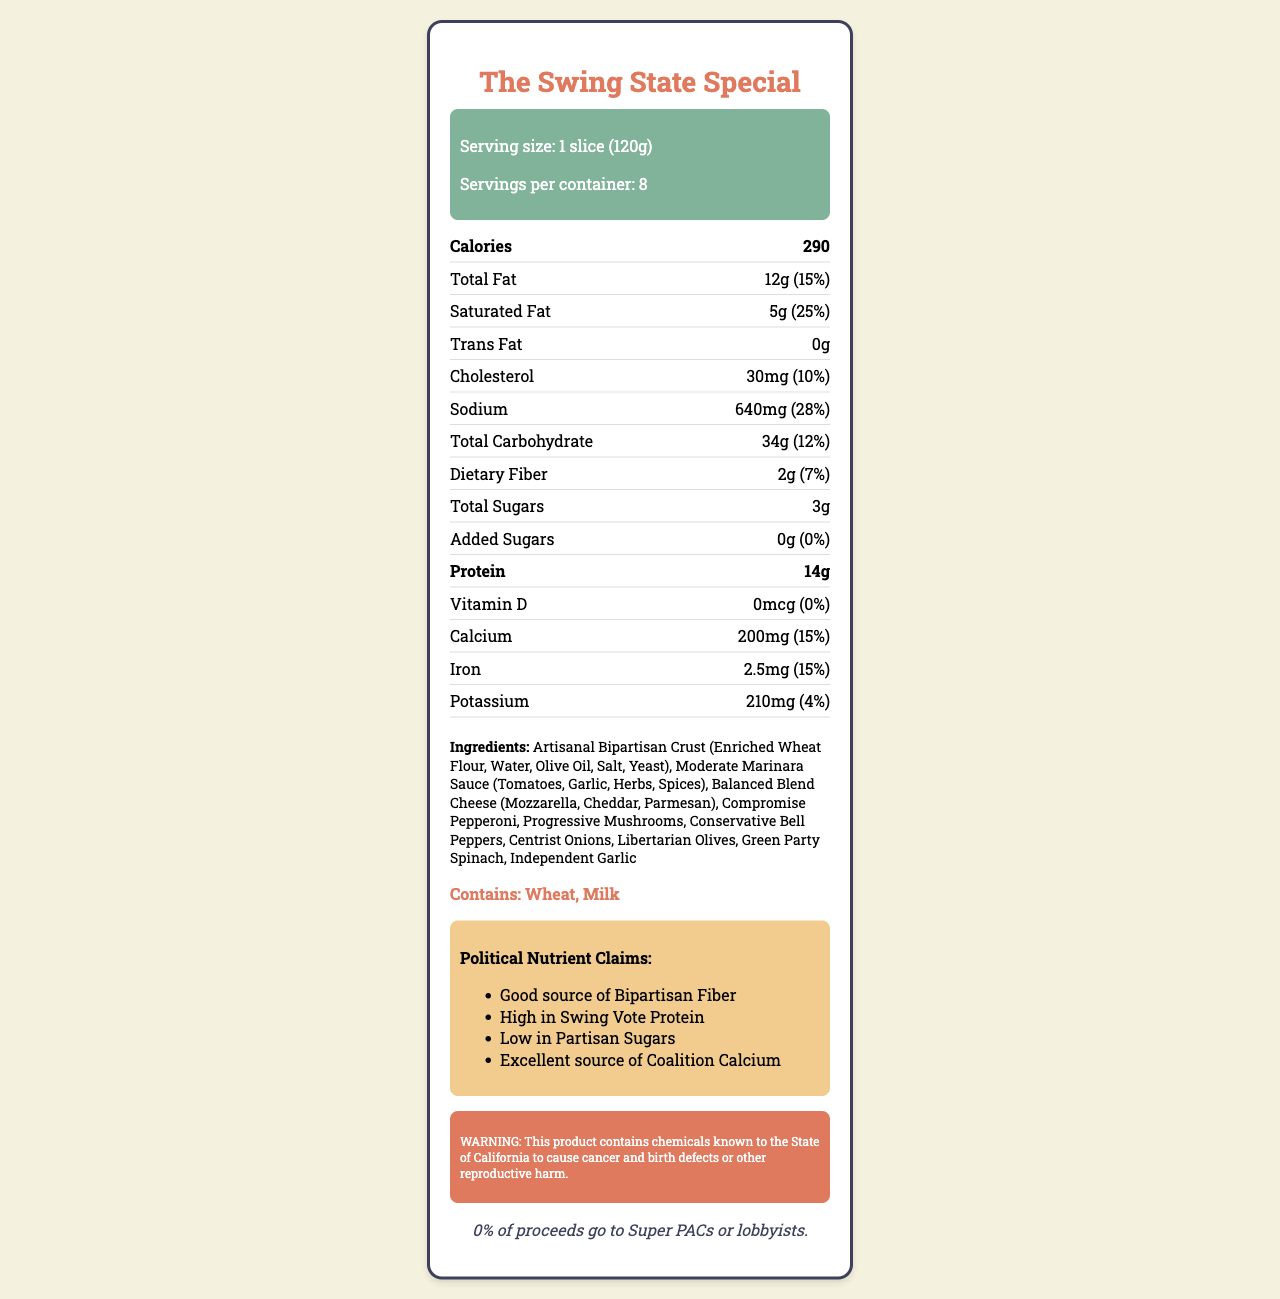what is the serving size for "The Swing State Special" pizza? The serving size for 'The Swing State Special' pizza is shown as 1 slice (120g) in the "Serving size" section.
Answer: 1 slice (120g) how many servings are there per container? The document states that there are 8 servings per container in the "Servings per container" section.
Answer: 8 what are the total calories in one serving? The number of calories in one serving is listed as 290 in the "Calories" section.
Answer: 290 what are the political nutrient claims mentioned? The "Political Nutrient Claims" section lists four claims: "Good source of Bipartisan Fiber", "High in Swing Vote Protein", "Low in Partisan Sugars", and "Excellent source of Coalition Calcium".
Answer: Good source of Bipartisan Fiber, High in Swing Vote Protein, Low in Partisan Sugars, Excellent source of Coalition Calcium what allergens are present in the pizza? The "Allergens" section specifies that the pizza contains Wheat and Milk.
Answer: Wheat, Milk how much total fat is in one slice (in grams)? A. 10g B. 12g C. 14g D. 16g The total fat in one slice is listed as 12g in the "Total Fat" section.
Answer: B what is the daily value percentage of sodium in one serving? A. 18% B. 20% C. 25% D. 28% The daily value percentage of sodium in one serving is 28%, as indicated in the "Sodium" section.
Answer: D does the product contain any Trans Fat? The "Trans Fat" section shows 0g, indicating that the product does not contain any Trans Fat.
Answer: No what ingredients make up the "Balanced Blend Cheese"? The "Ingredients" section lists the components of the "Balanced Blend Cheese" as Mozzarella, Cheddar, and Parmesan.
Answer: Mozzarella, Cheddar, Parmesan does this pizza meet any dietary fiber claims? The document mentions "Good source of Bipartisan Fiber" in the "Political Nutrient Claims" section, indicating a dietary fiber claim.
Answer: Yes summarize the main idea of the document. The Nutrition Facts Label provides comprehensive information about the "The Swing State Special" pizza, including its nutritional content, ingredients, allergen information, and specific political nutrient claims, along with a Proposition 65 warning and a statement about the absence of Super PAC financing.
Answer: The document is a Nutrition Facts Label for "The Swing State Special" pizza, detailing its serving size, nutrients, ingredients, allergens, political nutrient claims, and warnings. is the product fortified with Vitamin D? The "Vitamin D" section shows 0mcg, which indicates that the product is not fortified with Vitamin D.
Answer: No how much protein is in one slice of the pizza? The "Protein" section indicates that there are 14g of protein in one slice of the pizza.
Answer: 14g what is the cholesterol content in one serving, and what is its daily value percentage? The "Cholesterol" section states that one serving contains 30mg of cholesterol, which is 10% of the daily value.
Answer: 30mg, 10% how many grams of dietary fiber are there in one slice? The "Dietary Fiber" section shows that there are 2g of dietary fiber in one slice.
Answer: 2g explain the finance-related statement regarding the pizza. The "Campaign Finance Statement" section clearly states that none of the proceeds from the pizza go towards Super PACs or lobbyists, suggesting a commitment to avoiding influence by political action committees or lobbying groups.
Answer: The statement specifies that 0% of proceeds go to Super PACs or lobbyists, emphasizing no political lobbying funds come from the sale of the pizza. what kind of olives are included in the pizza ingredients? The "Ingredients" section lists "Libertarian Olives" as one of the ingredients.
Answer: Libertarian Olives where does the data on saturated fat come from? The document shows the amount and daily value percentage of Saturated Fat, but it does not specify the source of this data.
Answer: Cannot be determined 